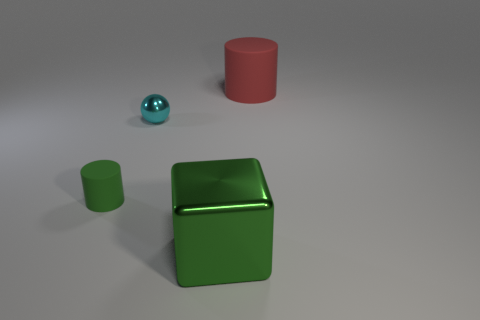Add 3 cyan things. How many objects exist? 7 Subtract all spheres. How many objects are left? 3 Add 2 cyan things. How many cyan things exist? 3 Subtract 0 cyan cylinders. How many objects are left? 4 Subtract all gray matte balls. Subtract all green objects. How many objects are left? 2 Add 3 tiny matte objects. How many tiny matte objects are left? 4 